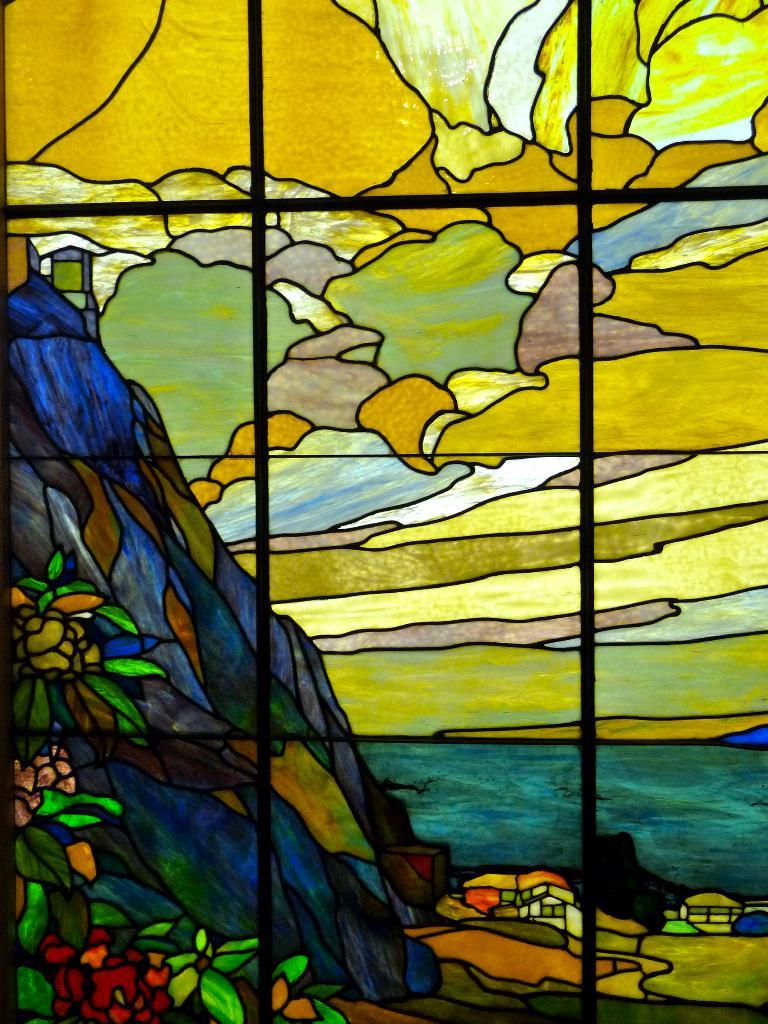What type of structure is depicted in the image? The image appears to be a window. What can be seen through the window? There are images of mountains, trees, and buildings visible through the window. Where is the water body located in relation to the window? The water body is on the right side of the window. What is visible at the top of the window? The sky is visible at the top of the window. Can you hear the thunder in the image? There is no sound present in the image, so it is not possible to hear thunder or any other sounds. 